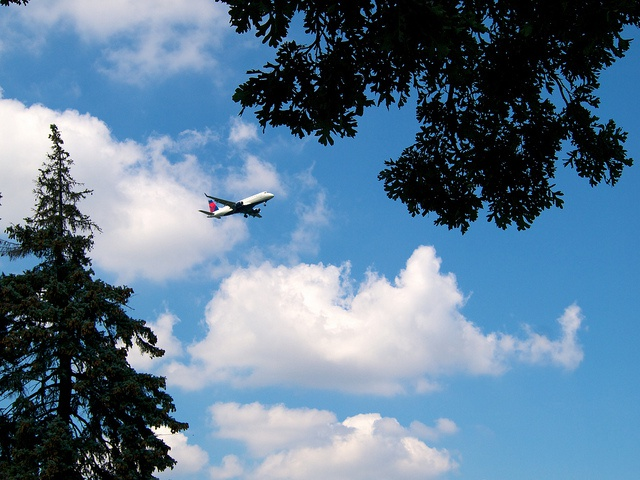Describe the objects in this image and their specific colors. I can see a airplane in teal, black, white, darkgray, and gray tones in this image. 